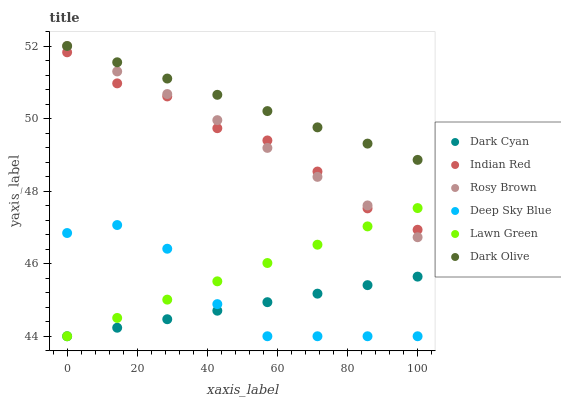Does Dark Cyan have the minimum area under the curve?
Answer yes or no. Yes. Does Dark Olive have the maximum area under the curve?
Answer yes or no. Yes. Does Indian Red have the minimum area under the curve?
Answer yes or no. No. Does Indian Red have the maximum area under the curve?
Answer yes or no. No. Is Lawn Green the smoothest?
Answer yes or no. Yes. Is Deep Sky Blue the roughest?
Answer yes or no. Yes. Is Dark Olive the smoothest?
Answer yes or no. No. Is Dark Olive the roughest?
Answer yes or no. No. Does Lawn Green have the lowest value?
Answer yes or no. Yes. Does Indian Red have the lowest value?
Answer yes or no. No. Does Rosy Brown have the highest value?
Answer yes or no. Yes. Does Indian Red have the highest value?
Answer yes or no. No. Is Deep Sky Blue less than Indian Red?
Answer yes or no. Yes. Is Rosy Brown greater than Deep Sky Blue?
Answer yes or no. Yes. Does Lawn Green intersect Rosy Brown?
Answer yes or no. Yes. Is Lawn Green less than Rosy Brown?
Answer yes or no. No. Is Lawn Green greater than Rosy Brown?
Answer yes or no. No. Does Deep Sky Blue intersect Indian Red?
Answer yes or no. No. 